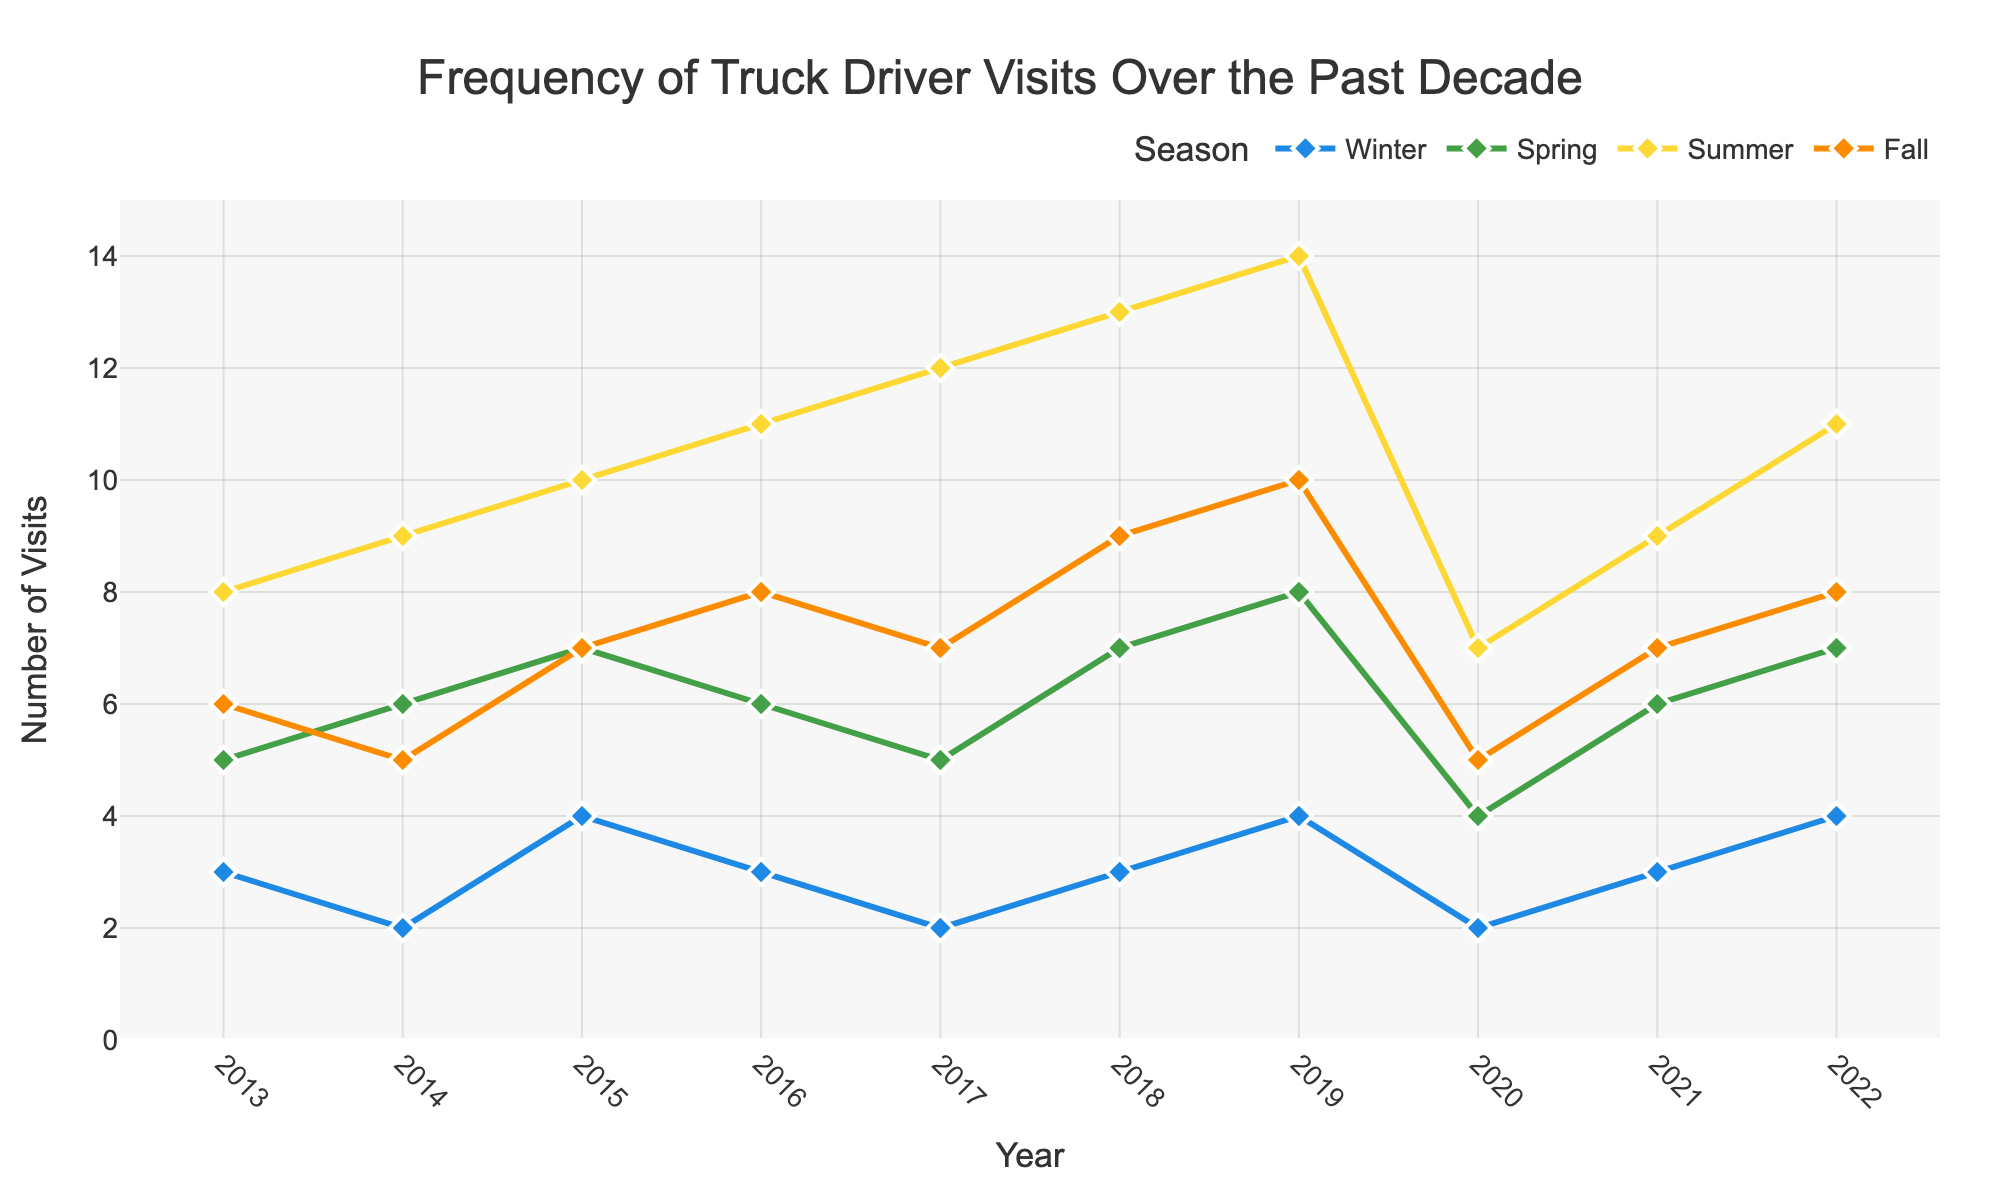What season had the highest number of truck driver visits in 2019? By examining the plot for the year 2019 and comparing the number of visits for each season, one can see that the summer had the highest number of visits.
Answer: Summer Which year had the least number of truck driver visits in winter? Looking at the winter line across the chart, the year with the lowest point is 2014, indicating the least number of truck driver visits in winter.
Answer: 2014 In how many seasons did visits increase between 2020 and 2021? To find how many seasons saw an increase, compare the values for each season between 2020 and 2021. Spring, Summer, and Fall saw an increase in visits between these years.
Answer: 3 seasons What is the average number of truck driver visits in Spring over the decade? Sum the number of visits in Spring from 2013 to 2022: (5+6+7+6+5+7+8+4+6+7) = 61, and then divide by the number of years, 10. The average is 61/10 = 6.1.
Answer: 6.1 Which season shows the most consistent pattern of visits over the years? By observing the lines representing each season, Winter appears the most consistent, displaying the least fluctuation in the number of visits over the years.
Answer: Winter What is the difference in the number of truck driver visits between Fall and Summer in 2017? In 2017, the Summer had 12 visits and Fall had 7 visits. The difference is 12 - 7.
Answer: 5 Identify the year with the maximum discrepancy between Summer and Winter visits. What is the difference? Calculate the difference for each year between Summer and Winter visits and find the maximum difference; 2019 had Summer with 14 visits and Winter with 4 visits, giving a discrepancy of 14 - 4.
Answer: 2019, 10 In which seasons did the number of truck driver visits exceed 10 visits in 2022, and how many visits were recorded? Refer to each season in 2022 and identify those with counts more than 10; Summer had 11 visits.
Answer: Summer, 11 How did the number of visits in Fall change from 2015 to 2016? Compare the values for Fall in 2015 and 2016. From 2015 to 2016, visits increased from 7 to 8.
Answer: Increased by 1 What is the trend in the number of visits during Summer from 2013 to 2022? Observing the Summer line from 2013 to 2022, it shows a generally increasing trend from 8 visits in 2013 to 11 visits in 2022.
Answer: Increasing trend 